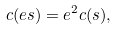Convert formula to latex. <formula><loc_0><loc_0><loc_500><loc_500>c ( e s ) = e ^ { 2 } c ( s ) ,</formula> 